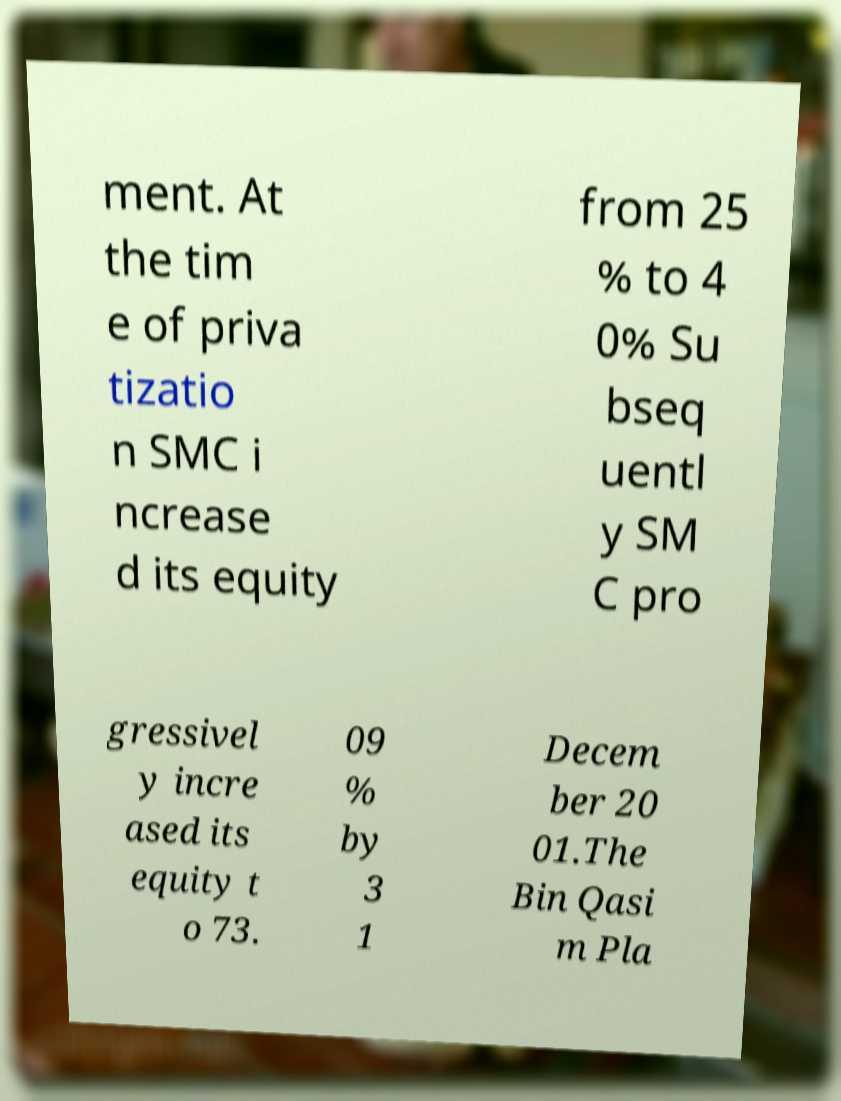Can you read and provide the text displayed in the image?This photo seems to have some interesting text. Can you extract and type it out for me? ment. At the tim e of priva tizatio n SMC i ncrease d its equity from 25 % to 4 0% Su bseq uentl y SM C pro gressivel y incre ased its equity t o 73. 09 % by 3 1 Decem ber 20 01.The Bin Qasi m Pla 